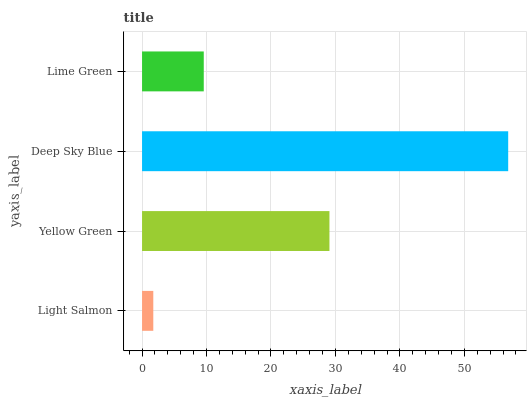Is Light Salmon the minimum?
Answer yes or no. Yes. Is Deep Sky Blue the maximum?
Answer yes or no. Yes. Is Yellow Green the minimum?
Answer yes or no. No. Is Yellow Green the maximum?
Answer yes or no. No. Is Yellow Green greater than Light Salmon?
Answer yes or no. Yes. Is Light Salmon less than Yellow Green?
Answer yes or no. Yes. Is Light Salmon greater than Yellow Green?
Answer yes or no. No. Is Yellow Green less than Light Salmon?
Answer yes or no. No. Is Yellow Green the high median?
Answer yes or no. Yes. Is Lime Green the low median?
Answer yes or no. Yes. Is Lime Green the high median?
Answer yes or no. No. Is Deep Sky Blue the low median?
Answer yes or no. No. 